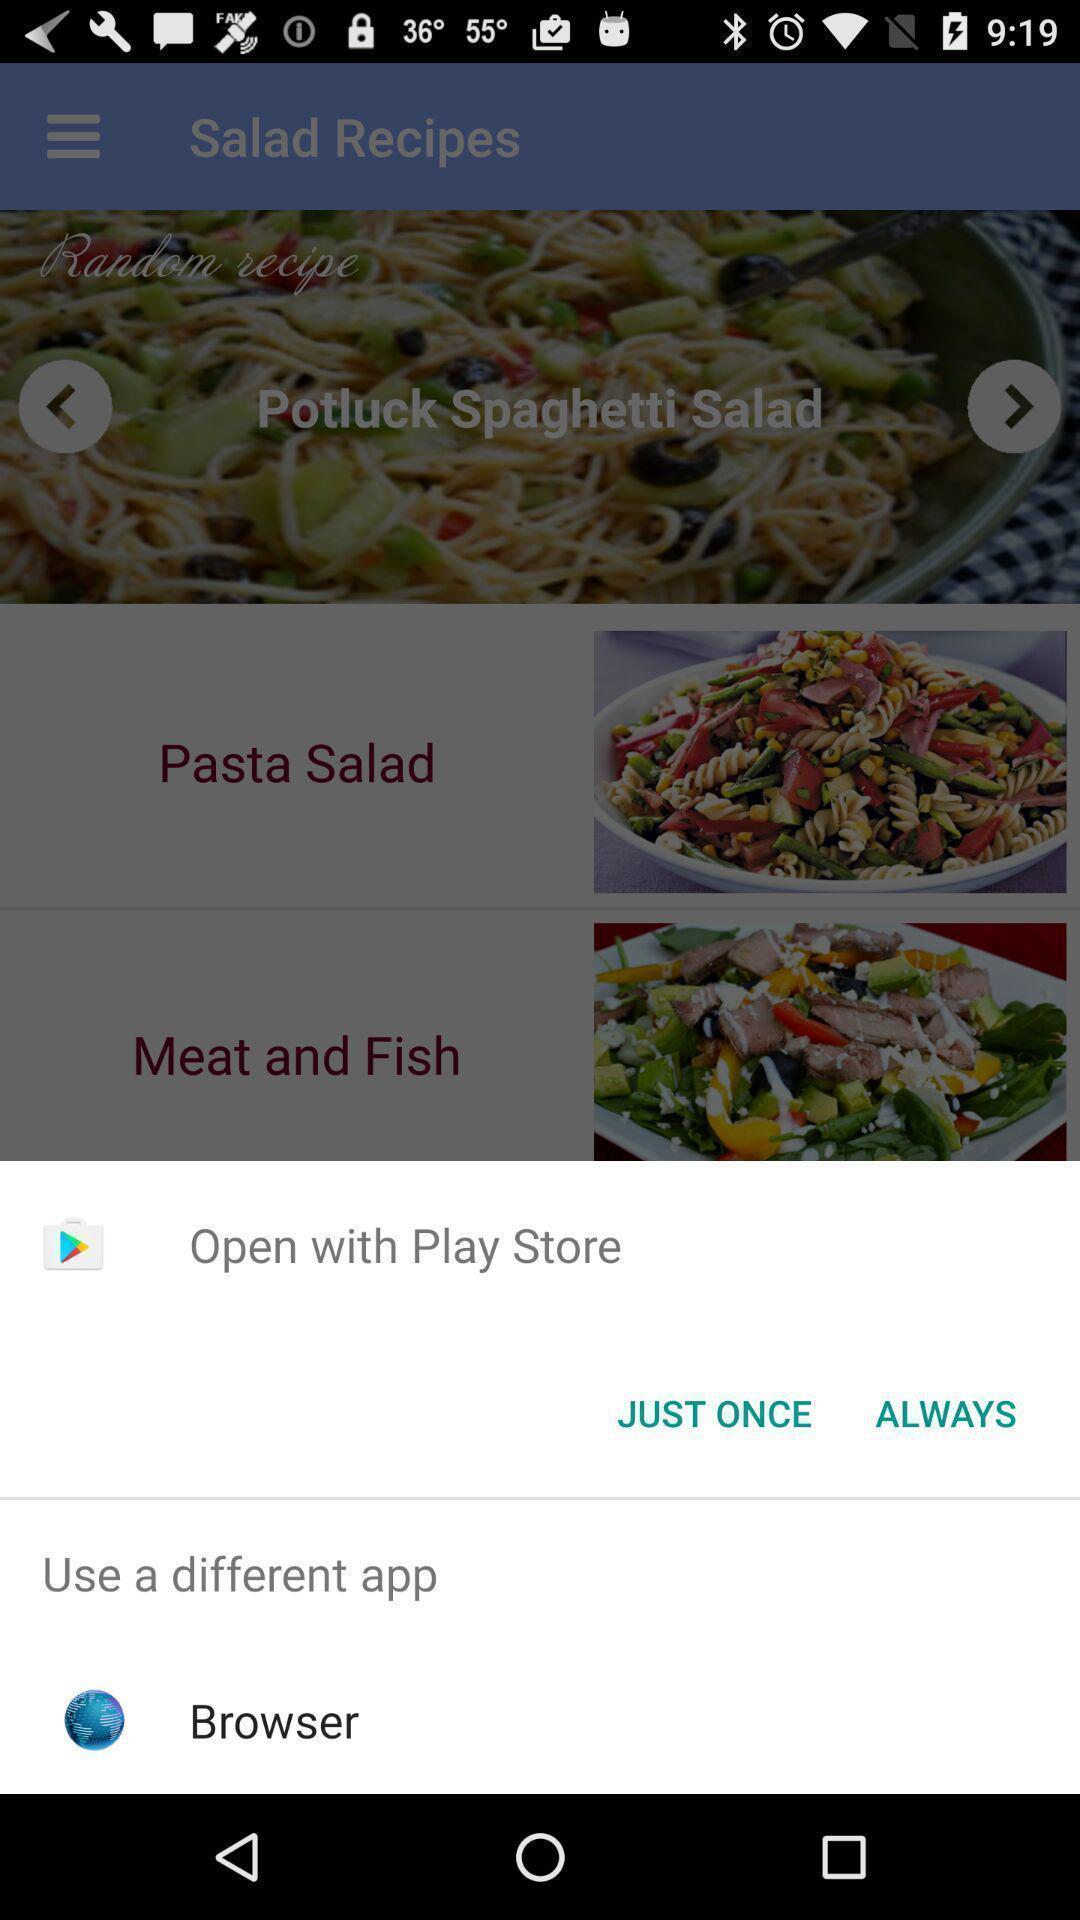Describe the visual elements of this screenshot. Pop-up to choose an app. 